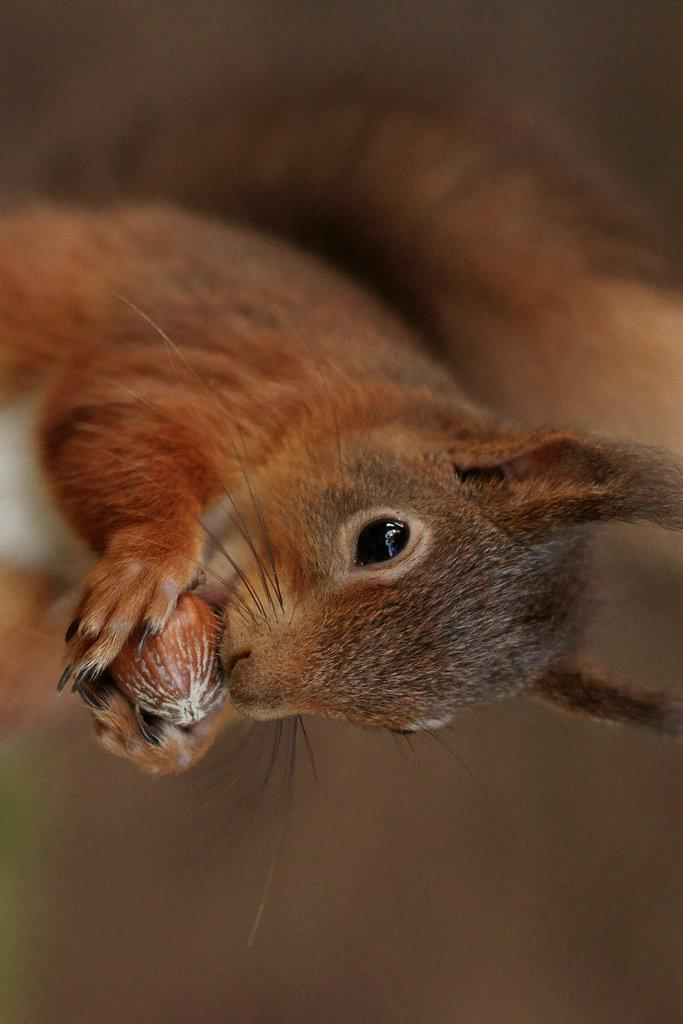What is the main subject of the picture? The main subject of the picture is a squirrel. How is the background of the image depicted? The background portion of the picture is blurred. What is the squirrel doing in the image? The squirrel is having food. What type of friction can be seen between the squirrel and the food in the image? There is no mention of friction in the image, as it focuses on the squirrel having food. What part of the squirrel's body is shown in the image? The image does not show any specific part of the squirrel's body; it only depicts the squirrel having food. 